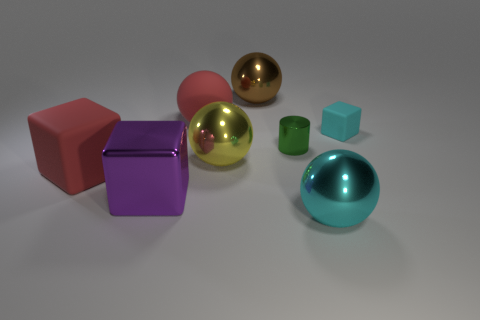Subtract all cyan spheres. How many spheres are left? 3 Subtract all cyan balls. How many balls are left? 3 Subtract all blue balls. Subtract all cyan cylinders. How many balls are left? 4 Add 1 big brown things. How many objects exist? 9 Subtract all cylinders. How many objects are left? 7 Subtract 0 gray cubes. How many objects are left? 8 Subtract all yellow shiny things. Subtract all cylinders. How many objects are left? 6 Add 3 balls. How many balls are left? 7 Add 3 big purple metal cubes. How many big purple metal cubes exist? 4 